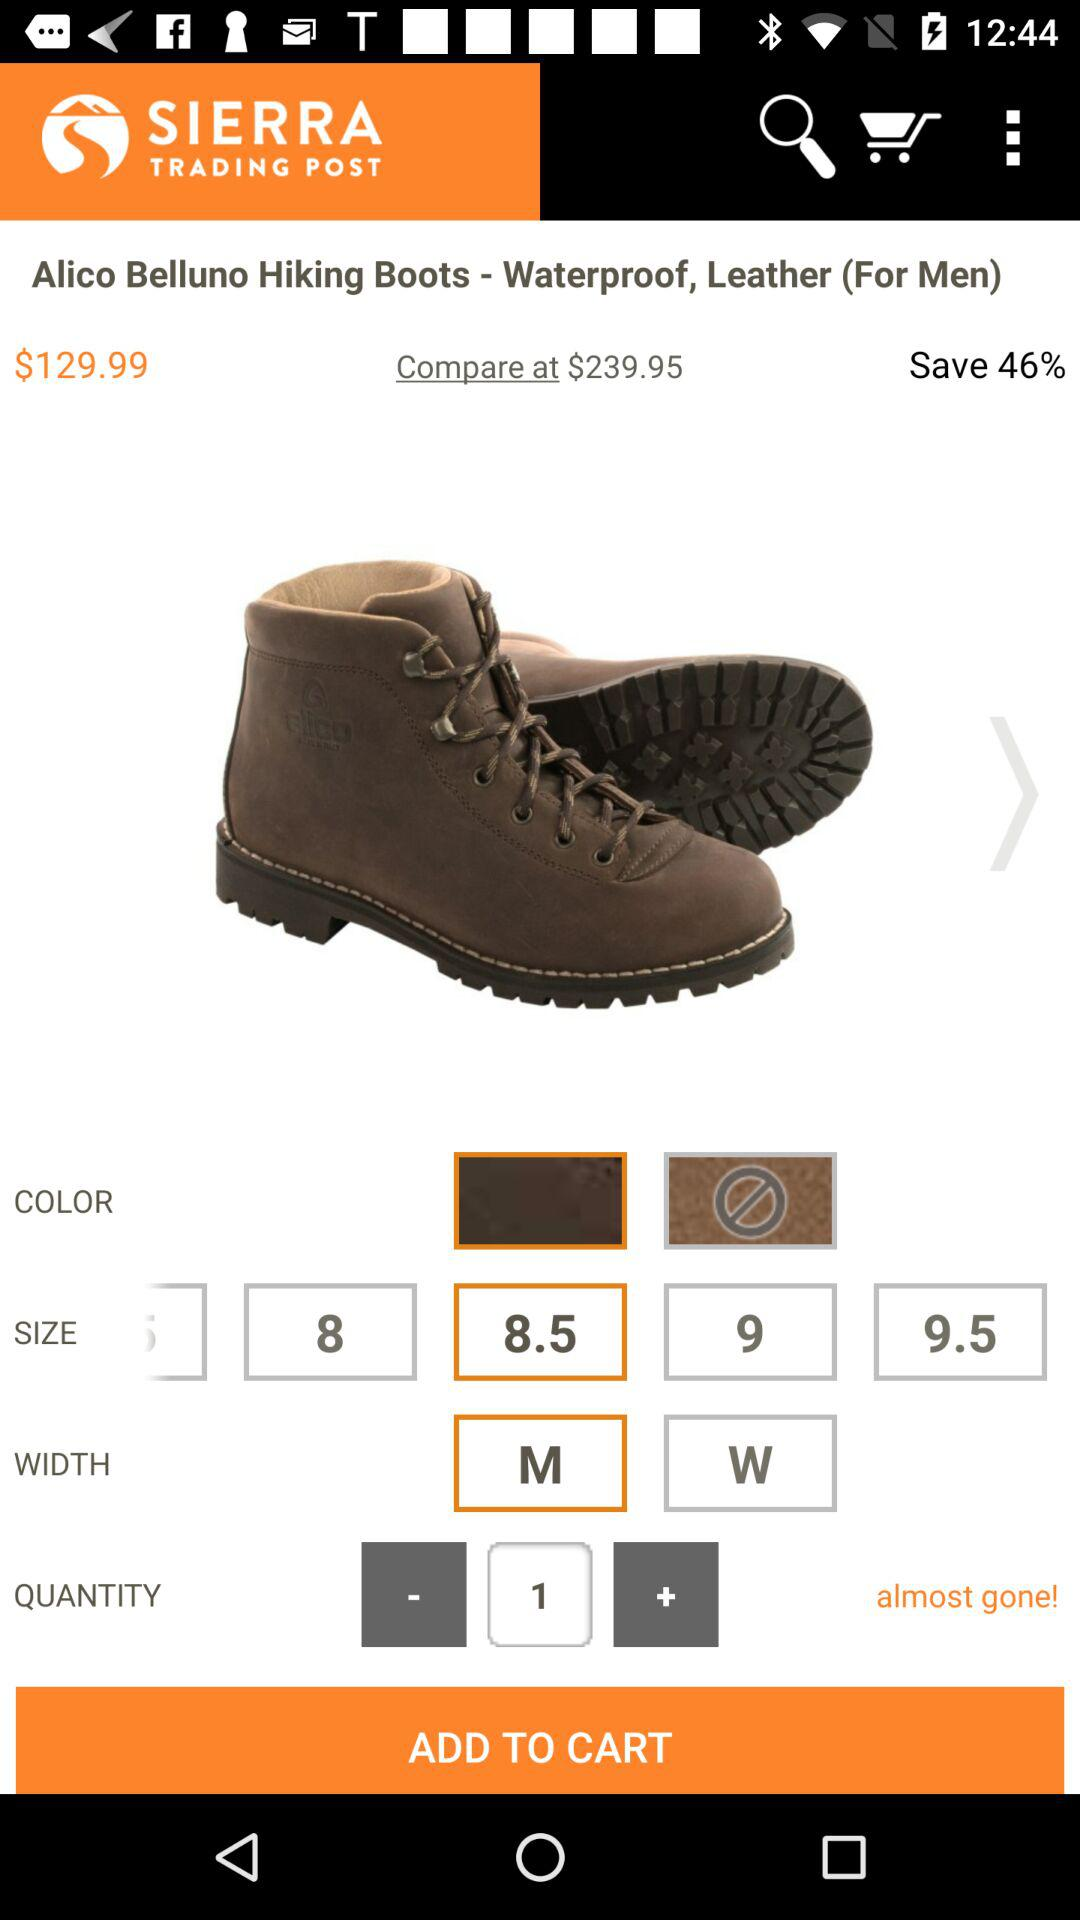For what gender is the product selected? The product is selected for men. 